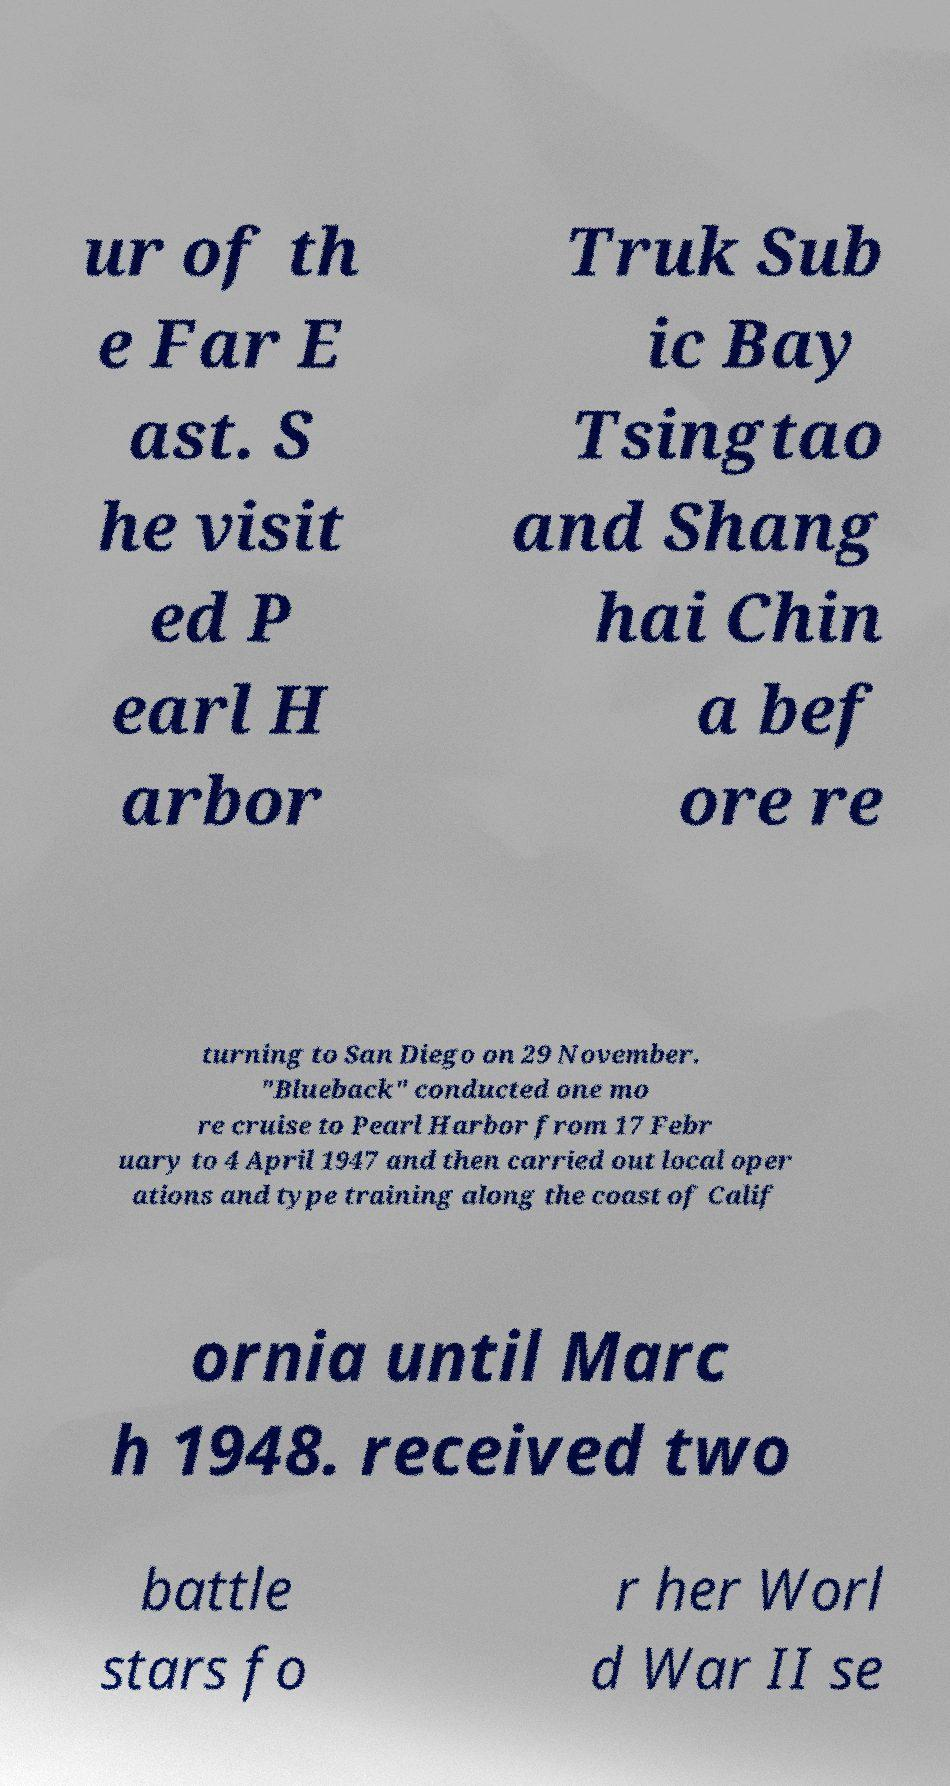There's text embedded in this image that I need extracted. Can you transcribe it verbatim? ur of th e Far E ast. S he visit ed P earl H arbor Truk Sub ic Bay Tsingtao and Shang hai Chin a bef ore re turning to San Diego on 29 November. "Blueback" conducted one mo re cruise to Pearl Harbor from 17 Febr uary to 4 April 1947 and then carried out local oper ations and type training along the coast of Calif ornia until Marc h 1948. received two battle stars fo r her Worl d War II se 